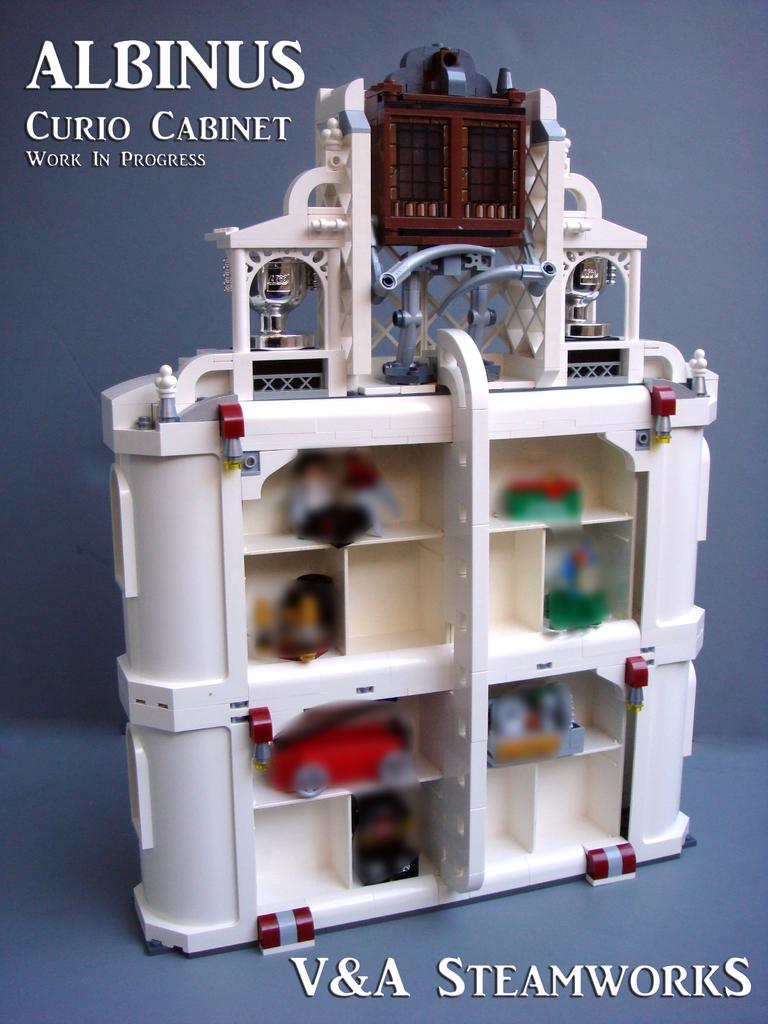<image>
Render a clear and concise summary of the photo. a white Albanus curio cabinet fro V&A Steamworks 